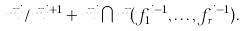Convert formula to latex. <formula><loc_0><loc_0><loc_500><loc_500>\vec { m } ^ { i } / \vec { m } ^ { i + 1 } + \vec { m } ^ { i } \bigcap \vec { m } ( f _ { 1 } ^ { i - 1 } , \dots , f _ { r } ^ { i - 1 } ) .</formula> 